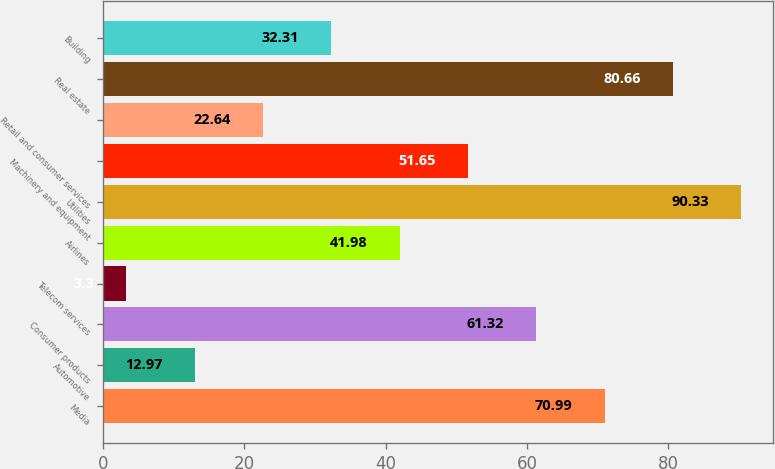Convert chart to OTSL. <chart><loc_0><loc_0><loc_500><loc_500><bar_chart><fcel>Media<fcel>Automotive<fcel>Consumer products<fcel>Telecom services<fcel>Airlines<fcel>Utilities<fcel>Machinery and equipment<fcel>Retail and consumer services<fcel>Real estate<fcel>Building<nl><fcel>70.99<fcel>12.97<fcel>61.32<fcel>3.3<fcel>41.98<fcel>90.33<fcel>51.65<fcel>22.64<fcel>80.66<fcel>32.31<nl></chart> 